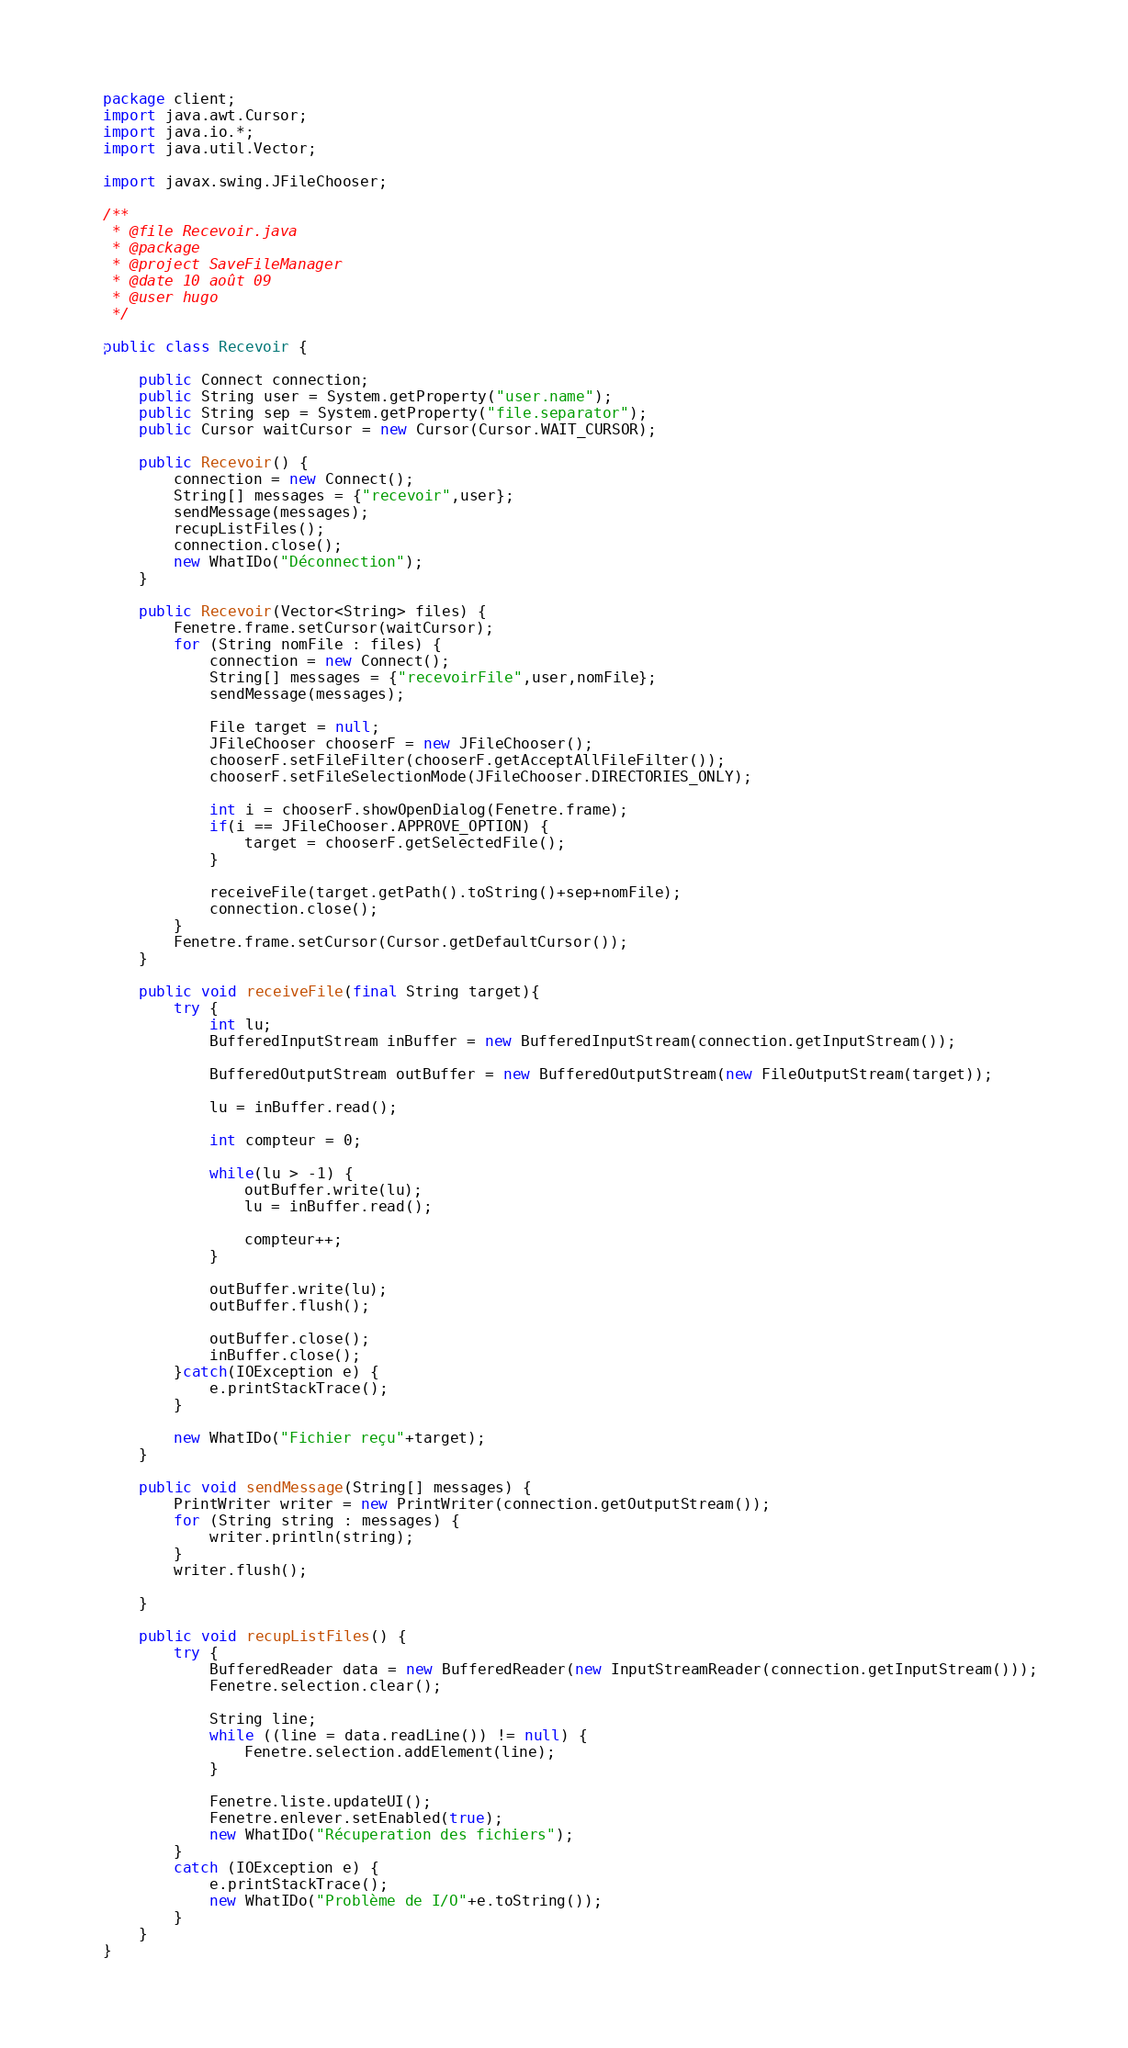<code> <loc_0><loc_0><loc_500><loc_500><_Java_>package client;
import java.awt.Cursor;
import java.io.*;
import java.util.Vector;

import javax.swing.JFileChooser;

/**
 * @file Recevoir.java
 * @package 
 * @project SaveFileManager
 * @date 10 août 09
 * @user hugo
 */

public class Recevoir {
	
	public Connect connection;
	public String user = System.getProperty("user.name");
	public String sep = System.getProperty("file.separator");
	public Cursor waitCursor = new Cursor(Cursor.WAIT_CURSOR);
	
	public Recevoir() {
		connection = new Connect();
		String[] messages = {"recevoir",user};
		sendMessage(messages);
		recupListFiles();
		connection.close();
		new WhatIDo("Déconnection"); 
	}

	public Recevoir(Vector<String> files) {
		Fenetre.frame.setCursor(waitCursor);
		for (String nomFile : files) {
			connection = new Connect();
			String[] messages = {"recevoirFile",user,nomFile};
			sendMessage(messages);
			
			File target = null;
			JFileChooser chooserF = new JFileChooser();
			chooserF.setFileFilter(chooserF.getAcceptAllFileFilter());
			chooserF.setFileSelectionMode(JFileChooser.DIRECTORIES_ONLY);
			
			int i = chooserF.showOpenDialog(Fenetre.frame);
			if(i == JFileChooser.APPROVE_OPTION) {
				target = chooserF.getSelectedFile();
			}
    		
			receiveFile(target.getPath().toString()+sep+nomFile);
			connection.close();
		}
		Fenetre.frame.setCursor(Cursor.getDefaultCursor());
	}
	
	public void receiveFile(final String target){
		try {
			int lu;
			BufferedInputStream inBuffer = new BufferedInputStream(connection.getInputStream());

			BufferedOutputStream outBuffer = new BufferedOutputStream(new FileOutputStream(target));

			lu = inBuffer.read();

			int compteur = 0;

			while(lu > -1) {
				outBuffer.write(lu);
				lu = inBuffer.read();

				compteur++;
			}

			outBuffer.write(lu);
			outBuffer.flush();

			outBuffer.close();
			inBuffer.close();
		}catch(IOException e) {
			e.printStackTrace();
		}

		new WhatIDo("Fichier reçu"+target);
	}
	
	public void sendMessage(String[] messages) {
		PrintWriter writer = new PrintWriter(connection.getOutputStream());
		for (String string : messages) {
			writer.println(string);
		}
		writer.flush();
		
	}

	public void recupListFiles() {
		try {
			BufferedReader data = new BufferedReader(new InputStreamReader(connection.getInputStream()));
			Fenetre.selection.clear();

			String line;
			while ((line = data.readLine()) != null) {
				Fenetre.selection.addElement(line);
			}

			Fenetre.liste.updateUI();
			Fenetre.enlever.setEnabled(true);
			new WhatIDo("Récuperation des fichiers");
		}
		catch (IOException e) {
			e.printStackTrace();
			new WhatIDo("Problème de I/O"+e.toString());
		}
	}
}
</code> 